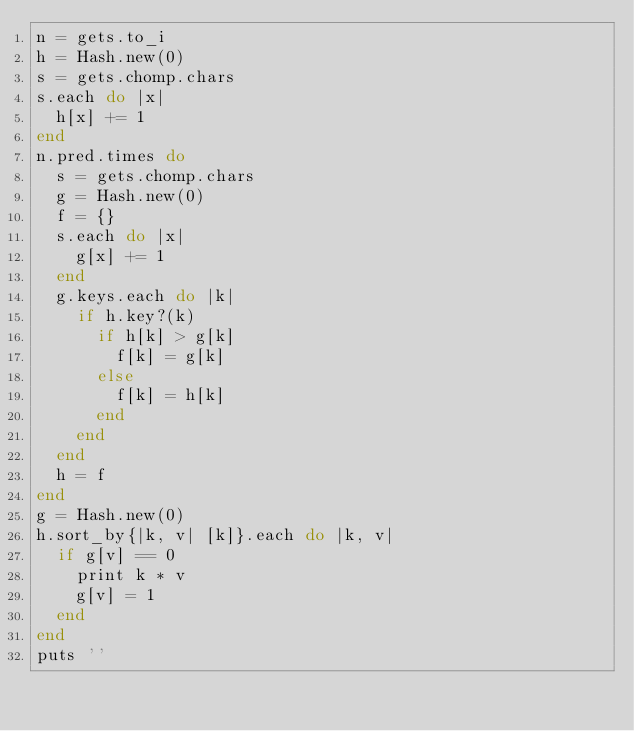<code> <loc_0><loc_0><loc_500><loc_500><_Ruby_>n = gets.to_i
h = Hash.new(0)
s = gets.chomp.chars
s.each do |x|
  h[x] += 1
end
n.pred.times do
  s = gets.chomp.chars
  g = Hash.new(0)
  f = {}
  s.each do |x|
    g[x] += 1
  end
  g.keys.each do |k|
    if h.key?(k)
      if h[k] > g[k]
        f[k] = g[k]
      else
        f[k] = h[k]
      end
    end
  end
  h = f
end
g = Hash.new(0)
h.sort_by{|k, v| [k]}.each do |k, v|
  if g[v] == 0
    print k * v
    g[v] = 1
  end
end
puts ''</code> 